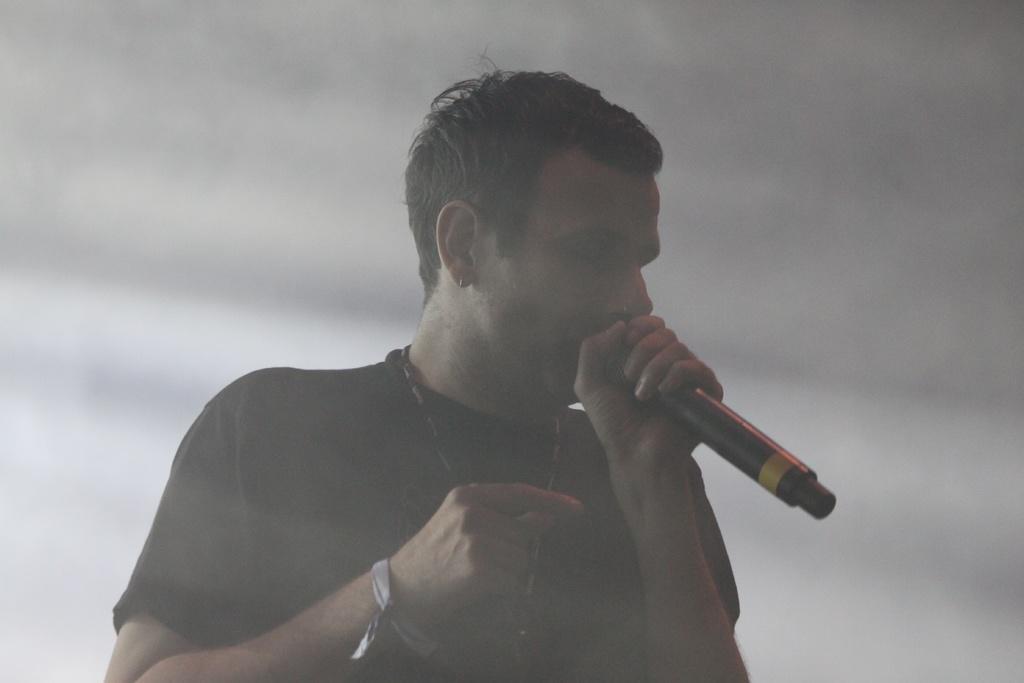Describe this image in one or two sentences. This is the picture of a man in black t shirt was holding a microphone and singing a song. Behind the man there is a smoke. 